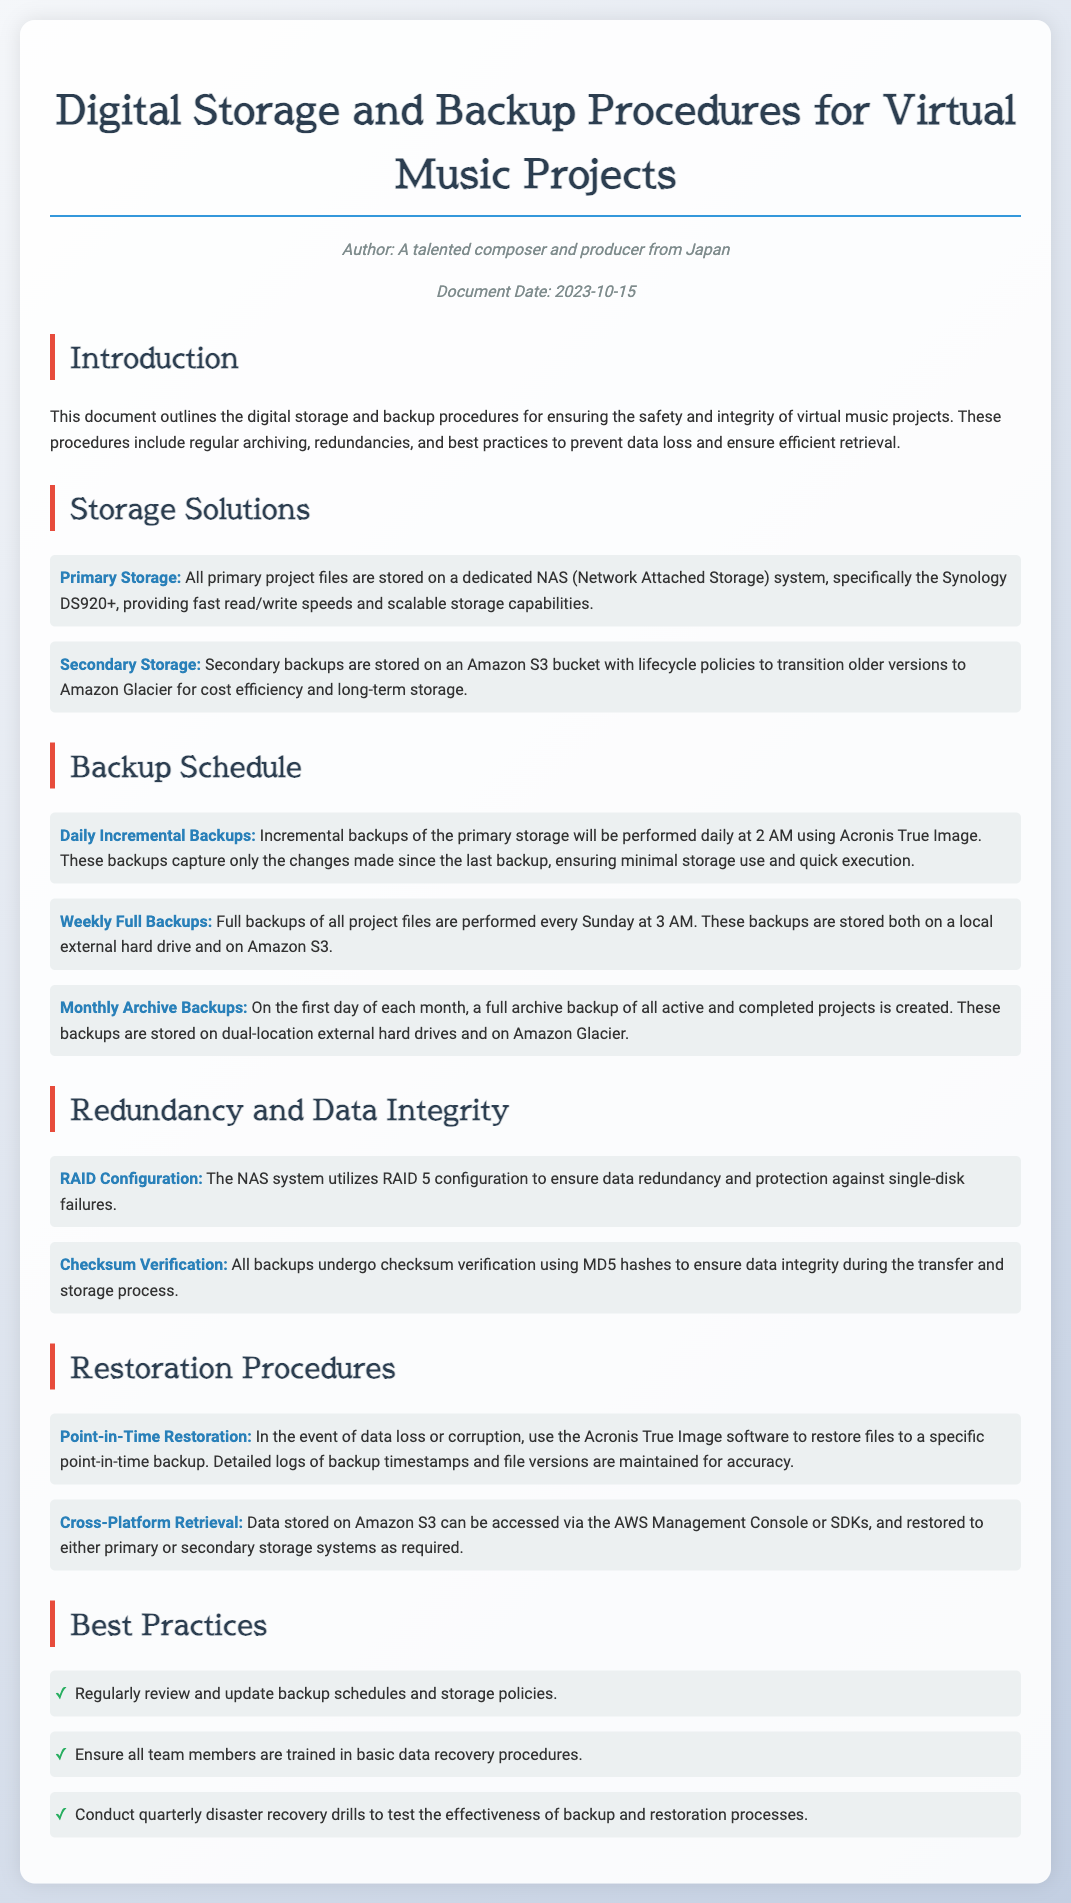What is the primary storage solution? The document specifies that all primary project files are stored on a dedicated NAS system, specifically the Synology DS920+.
Answer: Synology DS920+ When are the weekly full backups performed? The document states that full backups of all project files are performed every Sunday at 3 AM.
Answer: Every Sunday at 3 AM What type of RAID configuration is used? The document mentions that the NAS system utilizes RAID 5 configuration to ensure data redundancy and protection against single-disk failures.
Answer: RAID 5 How often are monthly archive backups created? The document indicates that a full archive backup of all active and completed projects is created on the first day of each month.
Answer: Monthly What software is used for point-in-time restoration? The document specifies that Acronis True Image software is used to restore files to a specific point-in-time backup.
Answer: Acronis True Image What is the procedure for checksum verification? The document informs that all backups undergo checksum verification using MD5 hashes to ensure data integrity during the transfer and storage process.
Answer: MD5 hashes How often should disaster recovery drills be conducted? The document recommends conducting quarterly disaster recovery drills to test the effectiveness of backup and restoration processes.
Answer: Quarterly What are the secondary storage solutions? The secondary backups are stored on an Amazon S3 bucket with lifecycle policies to transition older versions to Amazon Glacier.
Answer: Amazon S3 bucket and Amazon Glacier 